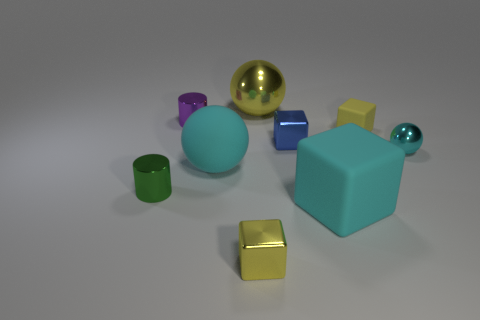The blue object that is the same size as the purple cylinder is what shape?
Provide a short and direct response. Cube. Is the number of cyan matte cubes greater than the number of big green shiny cylinders?
Give a very brief answer. Yes. There is a object that is on the left side of the cyan rubber block and in front of the small green thing; what is it made of?
Ensure brevity in your answer.  Metal. How many other objects are the same material as the tiny blue object?
Give a very brief answer. 5. What number of tiny metallic blocks are the same color as the small sphere?
Give a very brief answer. 0. What is the size of the cyan object in front of the cyan thing that is to the left of the small shiny block in front of the cyan rubber ball?
Give a very brief answer. Large. What number of rubber things are either small yellow things or big yellow things?
Your answer should be very brief. 1. Is the shape of the large yellow object the same as the big cyan matte object on the right side of the tiny blue object?
Offer a terse response. No. Are there more yellow shiny objects that are in front of the large cyan matte cube than tiny metallic cubes that are right of the small cyan ball?
Offer a very short reply. Yes. Is there a yellow shiny ball that is on the right side of the metallic cylinder that is in front of the cylinder behind the matte ball?
Keep it short and to the point. Yes. 